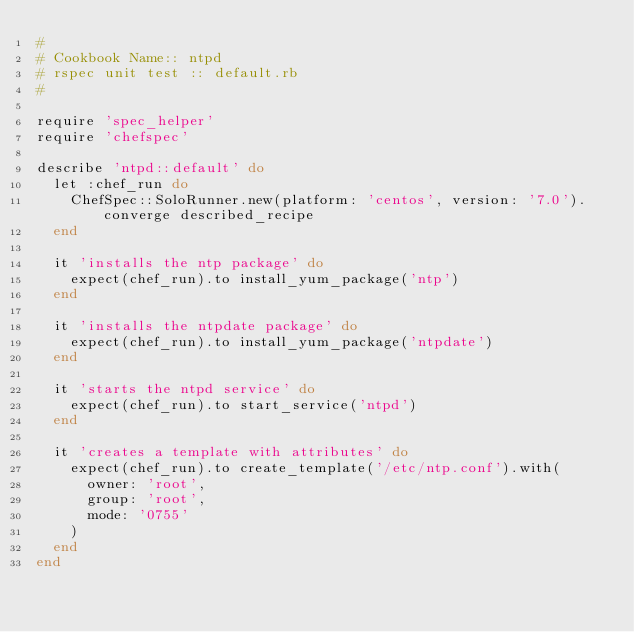<code> <loc_0><loc_0><loc_500><loc_500><_Ruby_>#
# Cookbook Name:: ntpd
# rspec unit test :: default.rb
#

require 'spec_helper'
require 'chefspec'

describe 'ntpd::default' do
  let :chef_run do
    ChefSpec::SoloRunner.new(platform: 'centos', version: '7.0').converge described_recipe
  end

  it 'installs the ntp package' do
    expect(chef_run).to install_yum_package('ntp')
  end

  it 'installs the ntpdate package' do
    expect(chef_run).to install_yum_package('ntpdate')
  end

  it 'starts the ntpd service' do
    expect(chef_run).to start_service('ntpd')
  end

  it 'creates a template with attributes' do
    expect(chef_run).to create_template('/etc/ntp.conf').with(
      owner: 'root',
      group: 'root',
      mode: '0755'
    )
  end
end
</code> 